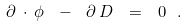Convert formula to latex. <formula><loc_0><loc_0><loc_500><loc_500>\partial \, \cdot \, \phi \ - \ \partial \, D \ = \ 0 \ .</formula> 